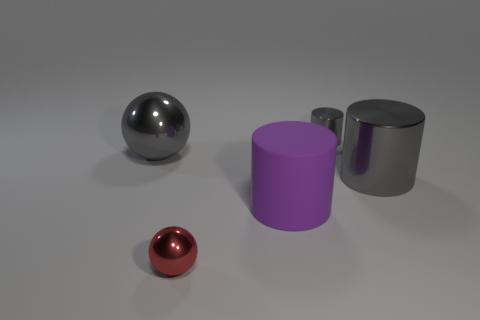Add 1 big gray metal balls. How many objects exist? 6 Subtract all balls. How many objects are left? 3 Add 2 tiny metallic cylinders. How many tiny metallic cylinders exist? 3 Subtract 0 cyan spheres. How many objects are left? 5 Subtract all matte cylinders. Subtract all purple rubber cylinders. How many objects are left? 3 Add 3 spheres. How many spheres are left? 5 